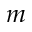<formula> <loc_0><loc_0><loc_500><loc_500>m</formula> 